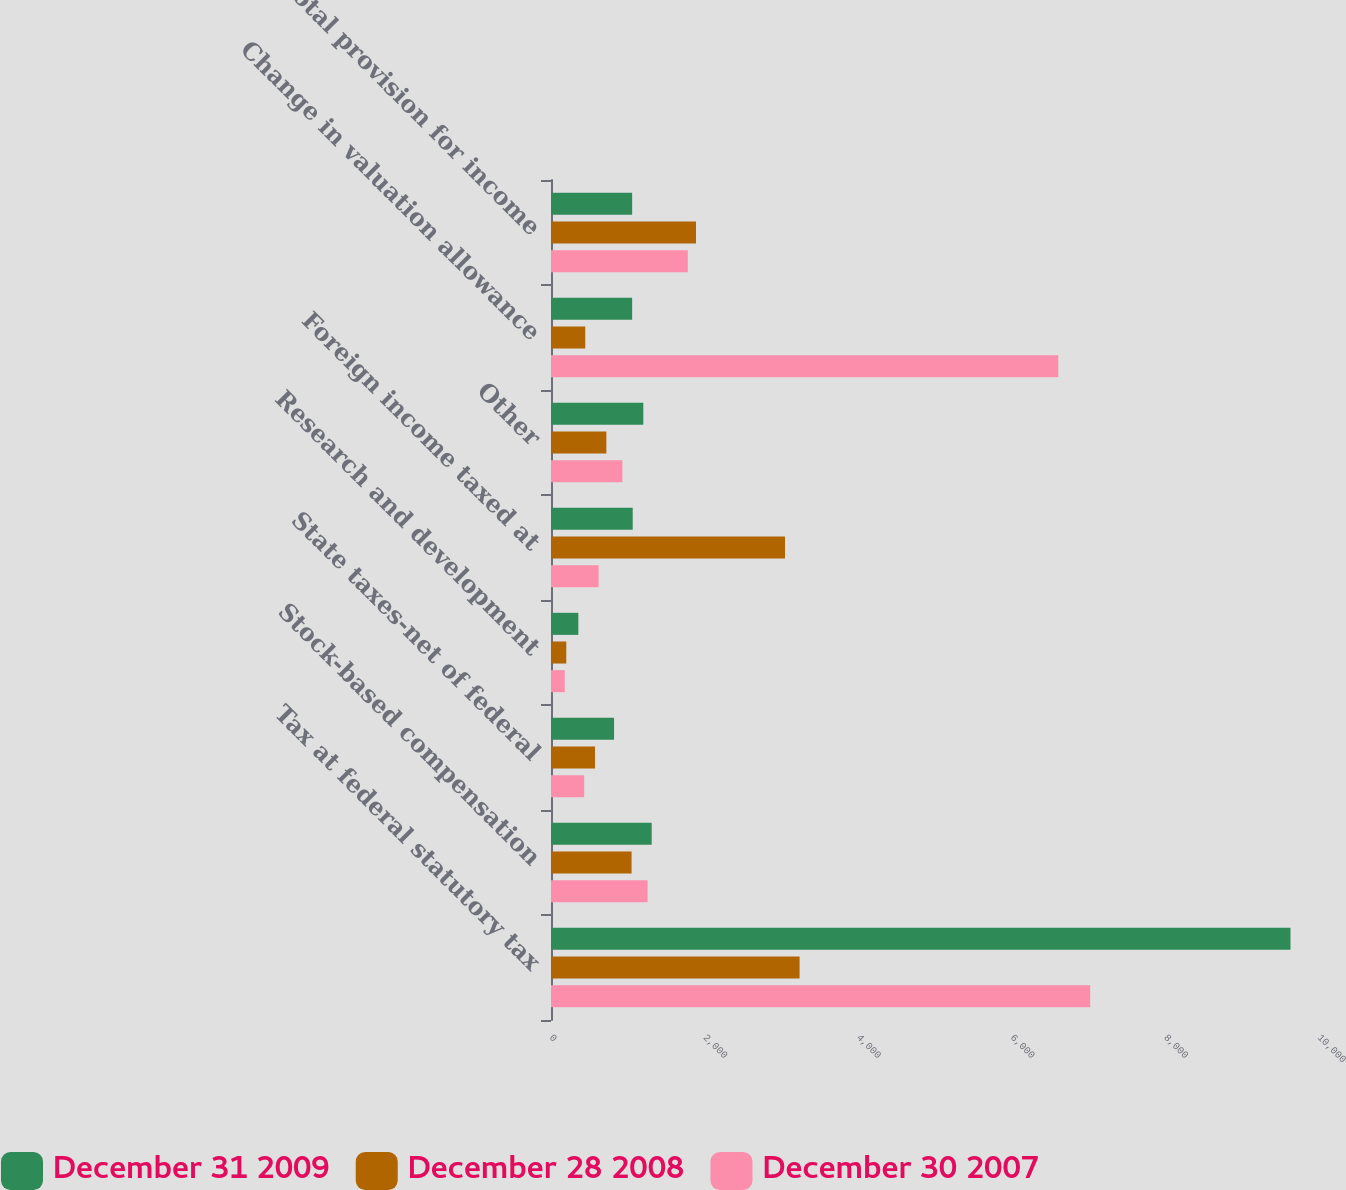Convert chart to OTSL. <chart><loc_0><loc_0><loc_500><loc_500><stacked_bar_chart><ecel><fcel>Tax at federal statutory tax<fcel>Stock-based compensation<fcel>State taxes-net of federal<fcel>Research and development<fcel>Foreign income taxed at<fcel>Other<fcel>Change in valuation allowance<fcel>Total provision for income<nl><fcel>December 31 2009<fcel>9629<fcel>1311<fcel>821<fcel>356<fcel>1064<fcel>1202<fcel>1056.5<fcel>1056.5<nl><fcel>December 28 2008<fcel>3237<fcel>1049<fcel>573<fcel>199<fcel>3047<fcel>721<fcel>446<fcel>1888<nl><fcel>December 30 2007<fcel>7021<fcel>1258<fcel>432<fcel>179<fcel>620<fcel>930<fcel>6605<fcel>1781<nl></chart> 